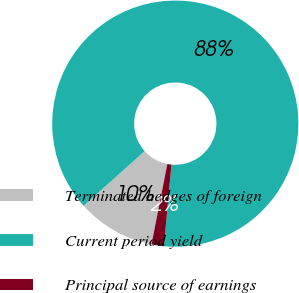Convert chart to OTSL. <chart><loc_0><loc_0><loc_500><loc_500><pie_chart><fcel>Terminated hedges of foreign<fcel>Current period yield<fcel>Principal source of earnings<nl><fcel>10.27%<fcel>88.1%<fcel>1.62%<nl></chart> 